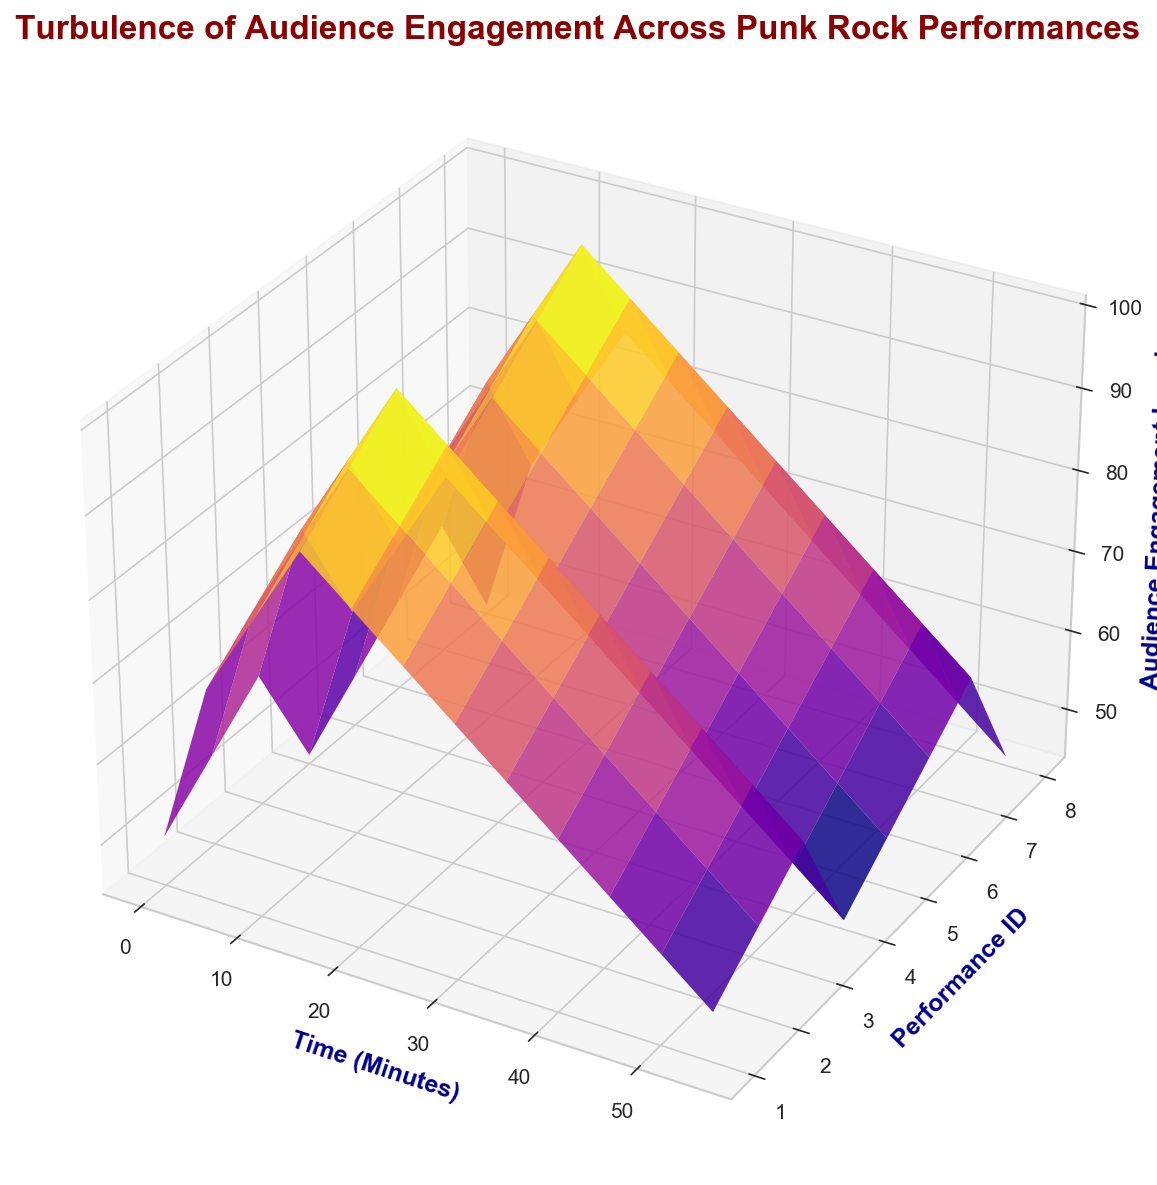What's the highest audience engagement level reached during all performances? Identify the peak of the 3D surface plot. The highest point visually represents the maximum audience engagement level.
Answer: 100 During which minute does the highest engagement occur for PerformanceID 3? Track the peak value within the plot for the plane corresponding to PerformanceID 3. Locate the X-axis value of this peak.
Answer: 15 Comparing PerformanceID 1 and PerformanceID 4, which has the lowest engagement at the 20th minute? Observe the engagement levels at the 20th minute for both performances in the plot and compare. PerformanceID 4's engagement is visually lower.
Answer: PerformanceID 4 Is there any performance where engagement increases consistently throughout its duration? Examine each performance's engagement trend over time. None of the plots show a consistent increase, some fluctuate or decrease after an initial rise.
Answer: No What is the average engagement level at the 15th minute across all performances? Sum the engagement levels at the 15th minute for all performances and divide by the number of performances. (90+95+100+85+90+95+100+85) / 8 = 92.5
Answer: 92.5 Which performance shows the most significant drop in engagement from the 10th to the 20th minute? Measure the difference in engagement levels between the 10th and 20th minutes for every performance. PerformanceID 3 shows a drop from 90 to 95, no drop. PerformanceID 4 drops from 75 to 80, etc.
Answer: None At which minute does the average engagement level exceed 80 for any performance? Calculate the average engagement level at each minute across all performances. The minute with an average above 80 would indicate where engagement exceeds this value. Peaks around minute 15 and 20.
Answer: 15 Which performance suffers a consistent decline in engagement after the peak? Identify the peak engagement for every performance and observe the trend immediately after the peak. PerformanceID 4 and 8 show such declining trends.
Answer: PerformanceID 4 and 8 Observing the 3D plot, which minute shows the most variability in engagement across performances? Look for the widest spread in Z-values (engagement) for any value on the X-axis (minutes). Minute 15 appears to have a broad range in engagement across performances.
Answer: 15 What's the steepest drop in engagement level in any performance? Observe the largest vertical drop within a short horizontal interval on the surface plot. Multiple steep drops denote possibly high variability, with many varying gradients noticed.
Answer: Multiple 